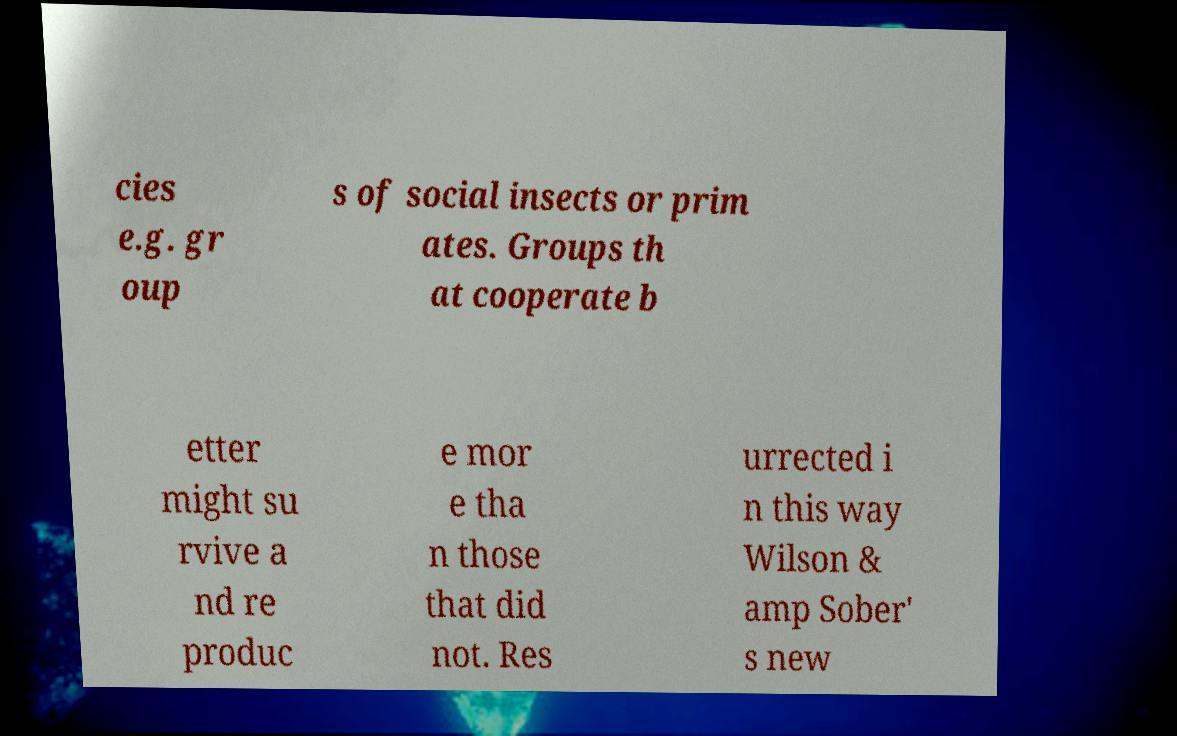Please identify and transcribe the text found in this image. cies e.g. gr oup s of social insects or prim ates. Groups th at cooperate b etter might su rvive a nd re produc e mor e tha n those that did not. Res urrected i n this way Wilson & amp Sober' s new 